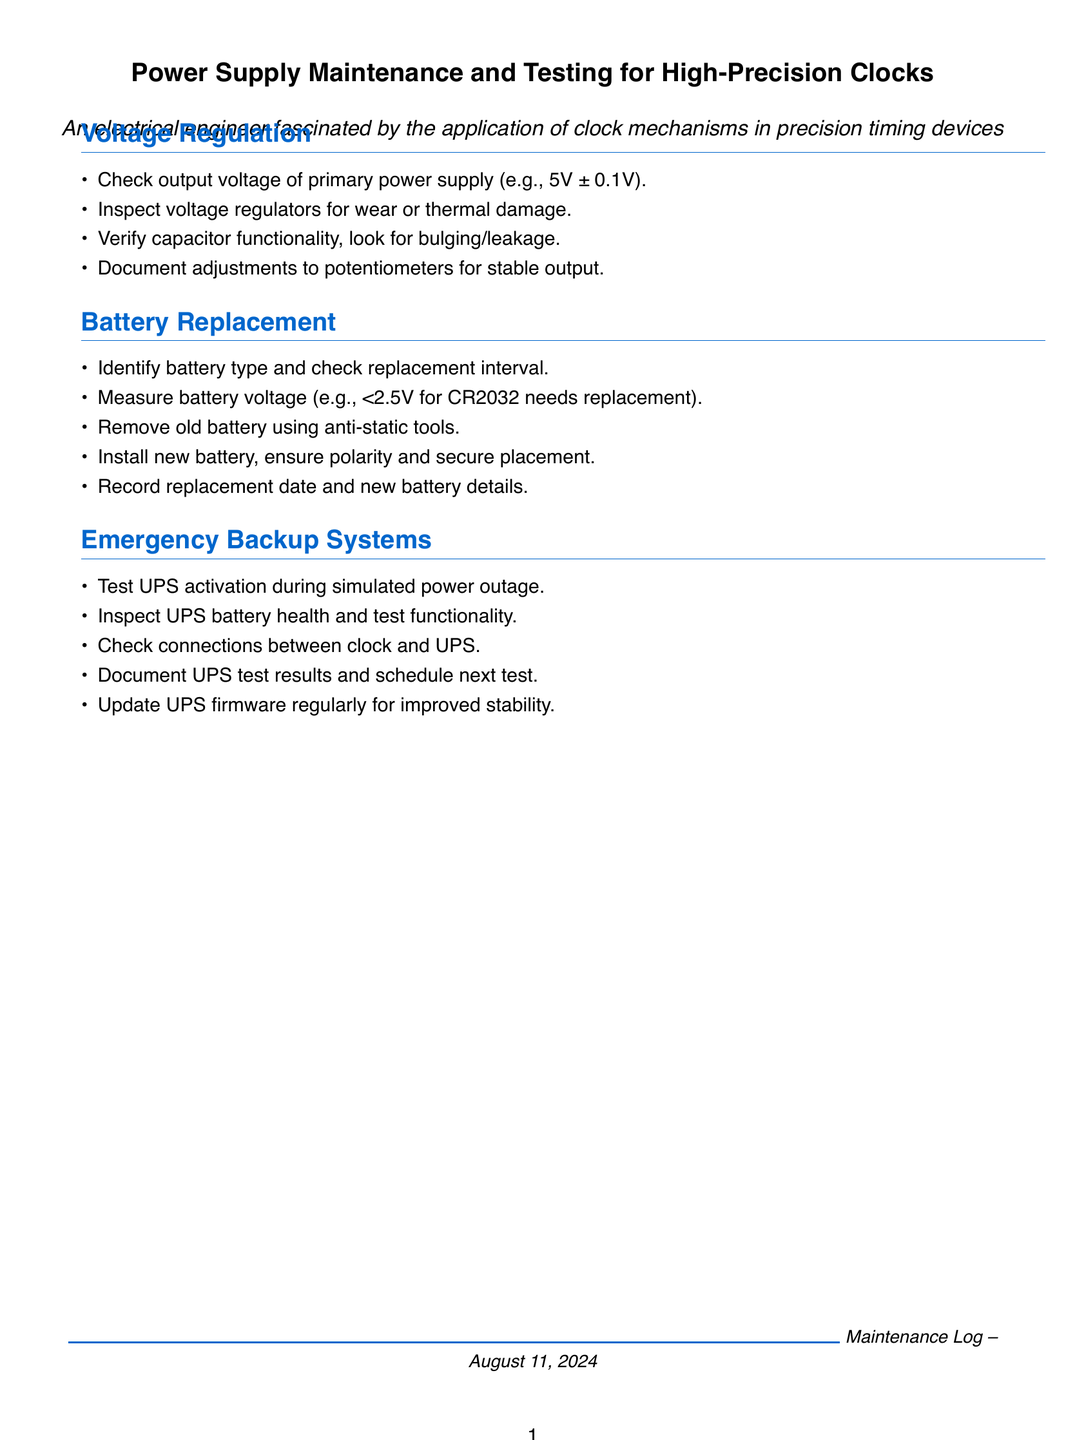What is the output voltage specification of the primary power supply? The output voltage specification is mentioned as 5V ± 0.1V in the document.
Answer: 5V ± 0.1V What battery type is mentioned for replacement? The document specifies CR2032 as the battery type that needs to be measured for voltage.
Answer: CR2032 What voltage indicates that the CR2032 battery needs replacement? The document states that a measurement of less than 2.5V indicates that the battery needs replacement.
Answer: <2.5V What is one condition to check for voltage regulators? The document mentions inspecting voltage regulators for wear or thermal damage.
Answer: Wear or thermal damage What is one action to take during UPS testing? The document states that one should test UPS activation during a simulated power outage.
Answer: Test UPS activation How often should UPS firmware be updated? The document suggests updating UPS firmware regularly to improve stability, although it does not specify a frequency.
Answer: Regularly What must be ensured when installing a new battery? The document highlights the necessity of ensuring correct polarity and secure placement during battery installation.
Answer: Polarity and secure placement What action should be documented after potentiometer adjustments? The document indicates that adjustments to potentiometers for stable output should be documented after the action is performed.
Answer: Document adjustments What should be checked between the clock and UPS? The document specifies checking connections between the clock and the UPS.
Answer: Connections 